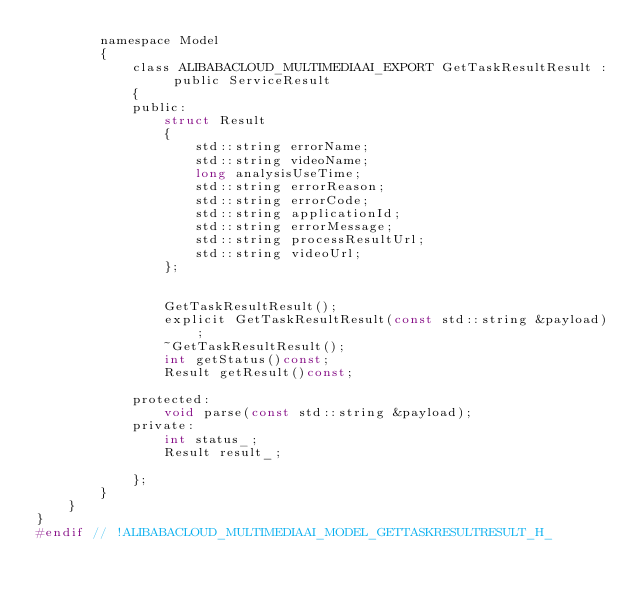Convert code to text. <code><loc_0><loc_0><loc_500><loc_500><_C_>		namespace Model
		{
			class ALIBABACLOUD_MULTIMEDIAAI_EXPORT GetTaskResultResult : public ServiceResult
			{
			public:
				struct Result
				{
					std::string errorName;
					std::string videoName;
					long analysisUseTime;
					std::string errorReason;
					std::string errorCode;
					std::string applicationId;
					std::string errorMessage;
					std::string processResultUrl;
					std::string videoUrl;
				};


				GetTaskResultResult();
				explicit GetTaskResultResult(const std::string &payload);
				~GetTaskResultResult();
				int getStatus()const;
				Result getResult()const;

			protected:
				void parse(const std::string &payload);
			private:
				int status_;
				Result result_;

			};
		}
	}
}
#endif // !ALIBABACLOUD_MULTIMEDIAAI_MODEL_GETTASKRESULTRESULT_H_</code> 